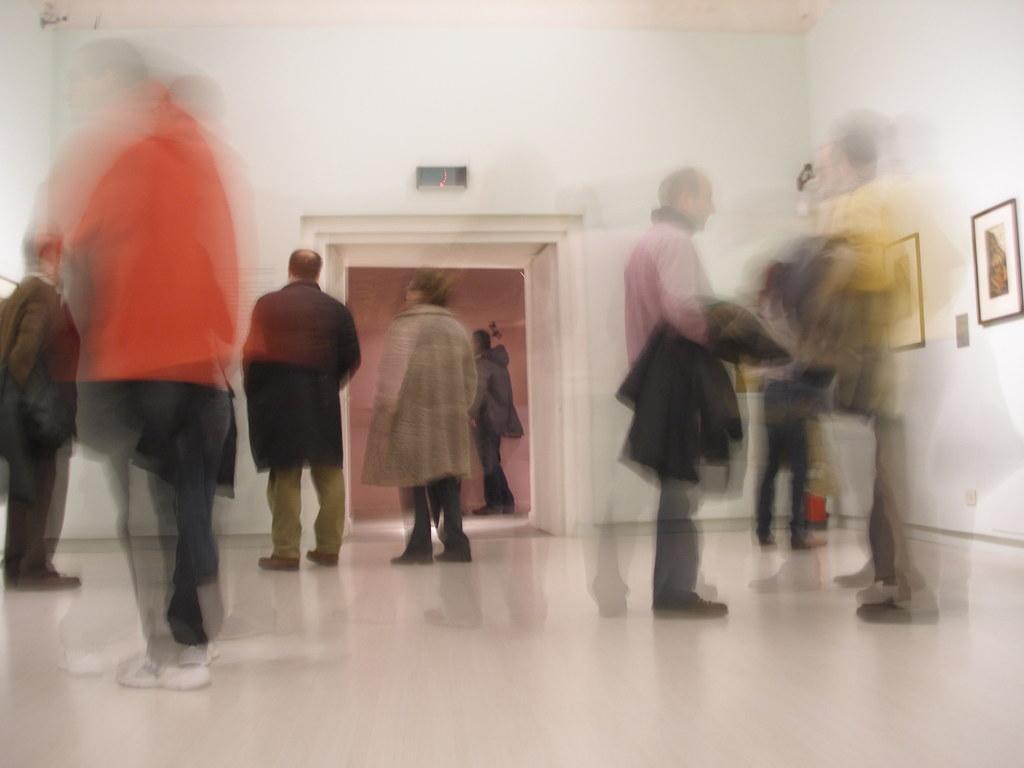Can you describe this image briefly? In this picture we can see people, they are blurred because they are moving. Towards right there is a wall and frames attached to the wall. In the middle of the picture there is a door and wall, outside the door we can see a person standing. At the bottom there is floor. 